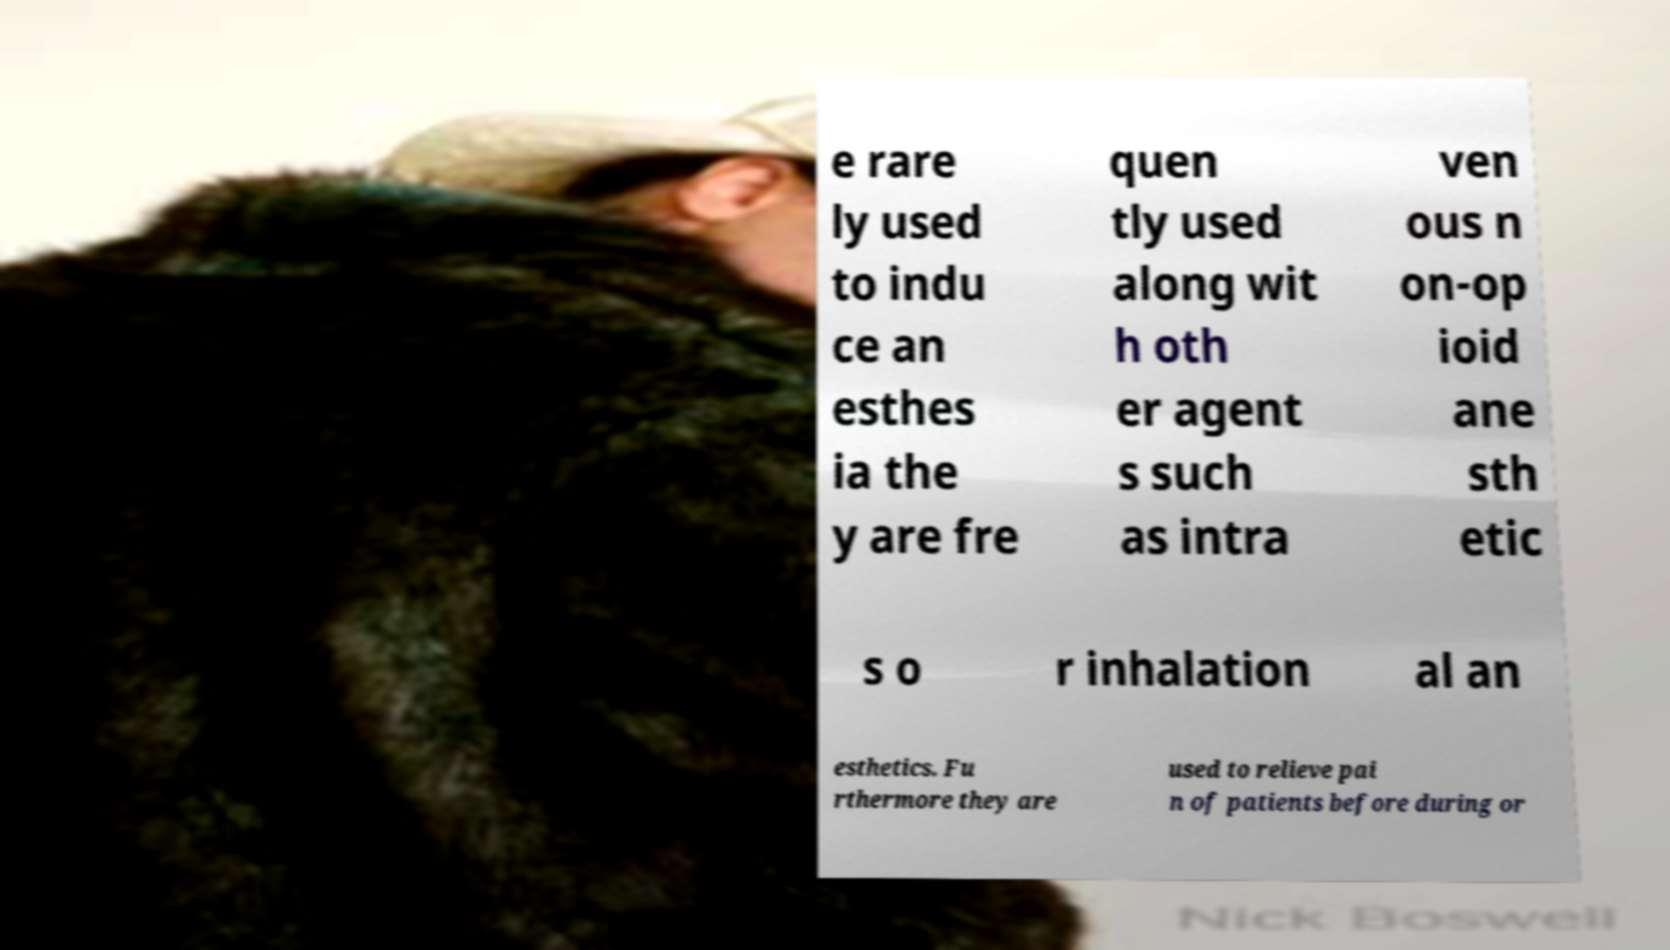Could you assist in decoding the text presented in this image and type it out clearly? e rare ly used to indu ce an esthes ia the y are fre quen tly used along wit h oth er agent s such as intra ven ous n on-op ioid ane sth etic s o r inhalation al an esthetics. Fu rthermore they are used to relieve pai n of patients before during or 